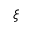<formula> <loc_0><loc_0><loc_500><loc_500>\xi</formula> 